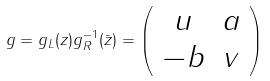<formula> <loc_0><loc_0><loc_500><loc_500>g = g _ { L } ( z ) g _ { R } ^ { - 1 } ( \bar { z } ) = \left ( \begin{array} { c c } { u } & { a } \\ { - b } & { v } \end{array} \right )</formula> 